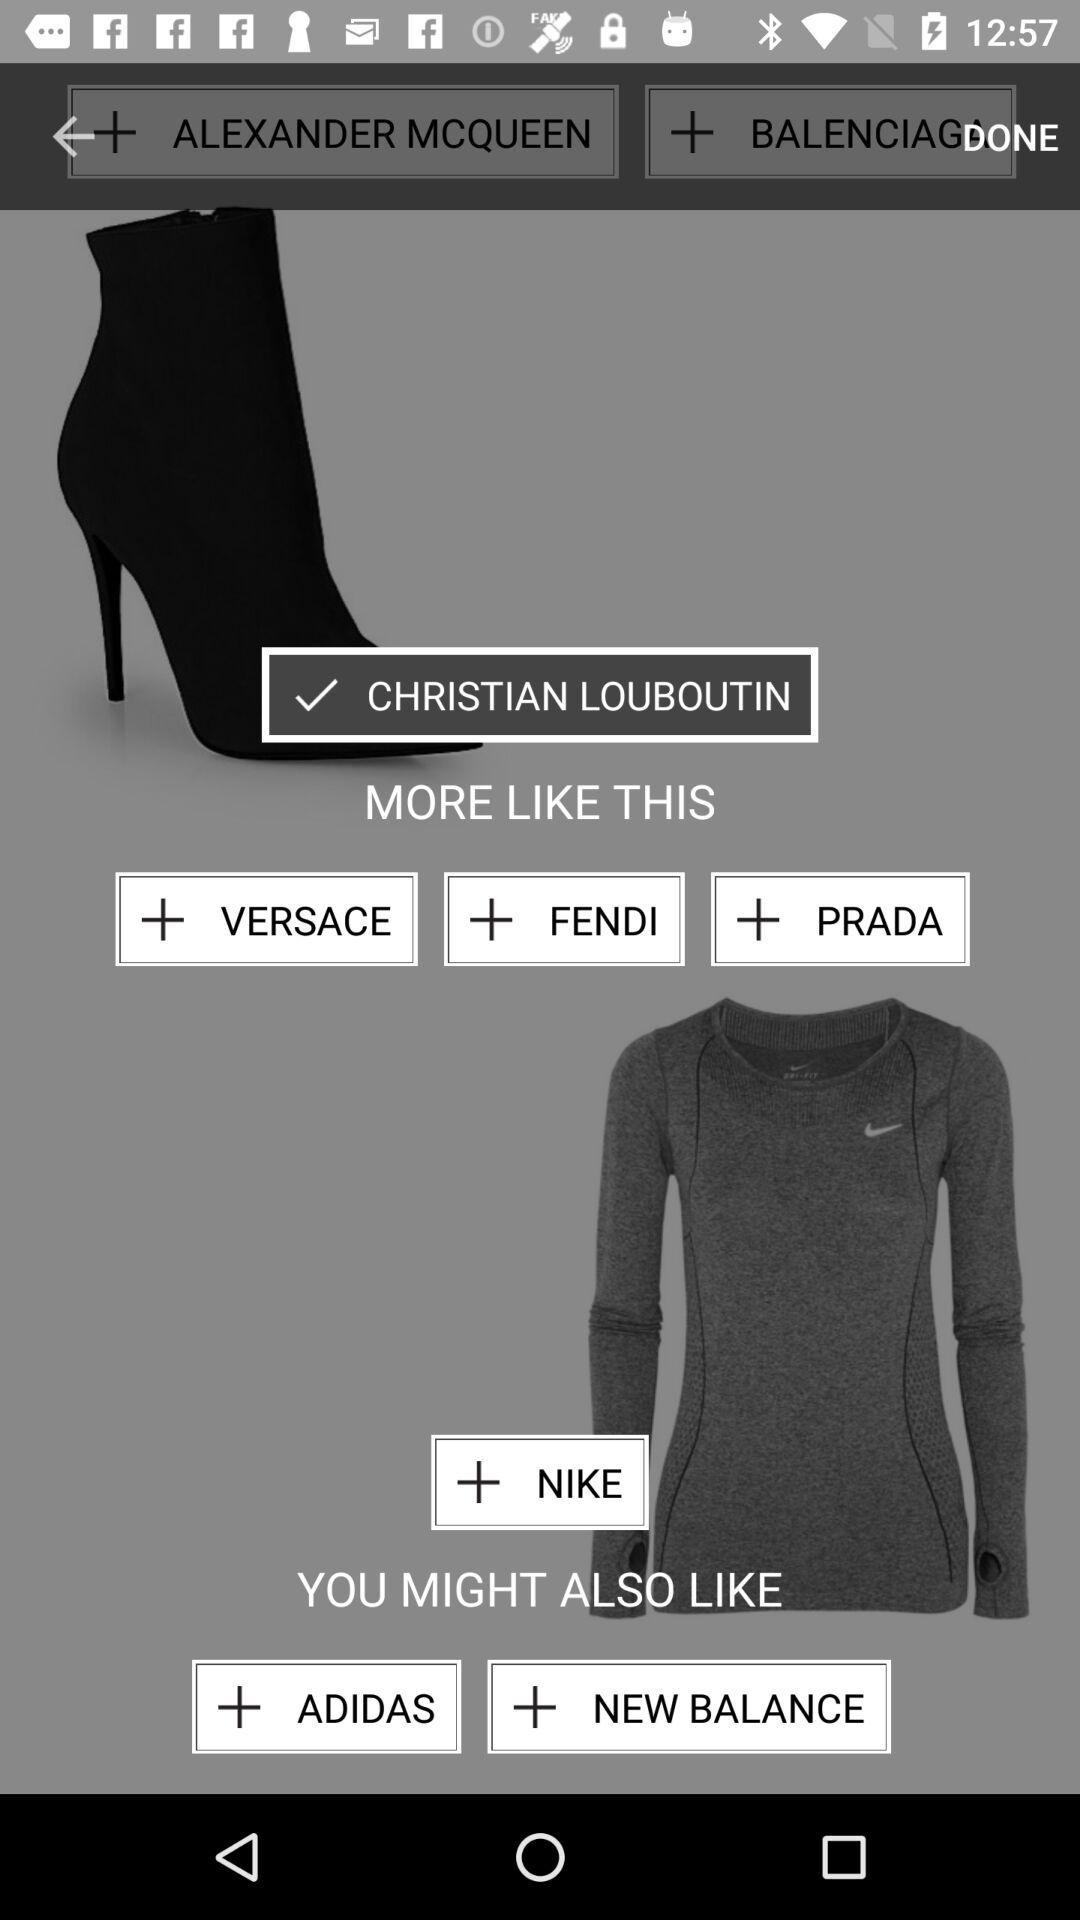Which brands might the user also like? The user might also like the brands "ADIDAS" and "NEW BALANCE". 